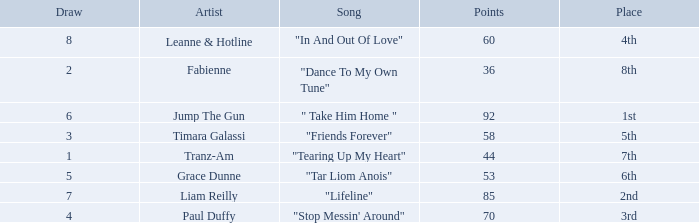What's the highest draw with over 60 points for paul duffy? 4.0. 